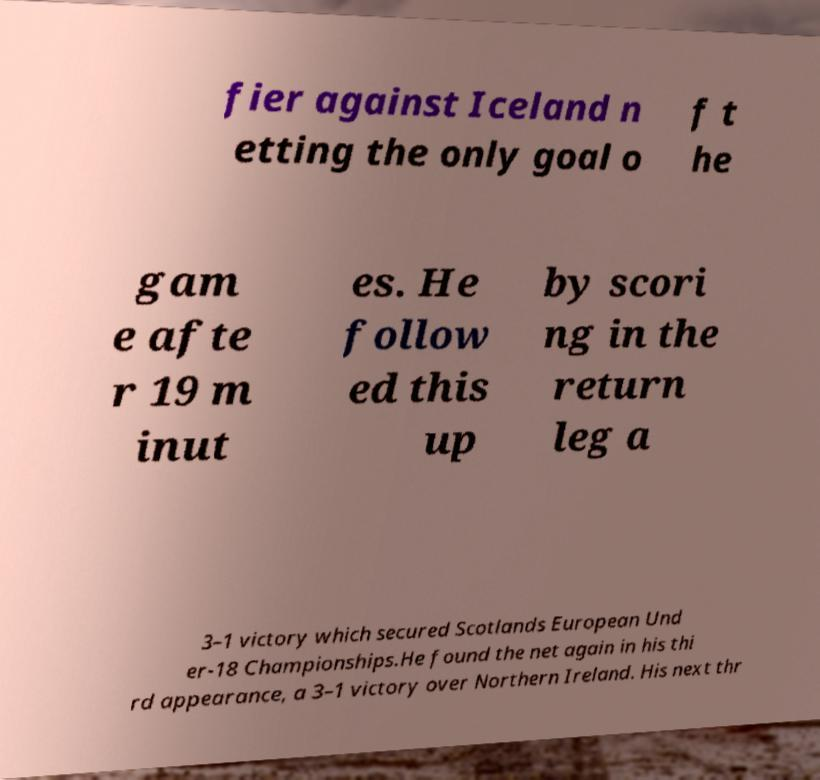Could you extract and type out the text from this image? fier against Iceland n etting the only goal o f t he gam e afte r 19 m inut es. He follow ed this up by scori ng in the return leg a 3–1 victory which secured Scotlands European Und er-18 Championships.He found the net again in his thi rd appearance, a 3–1 victory over Northern Ireland. His next thr 